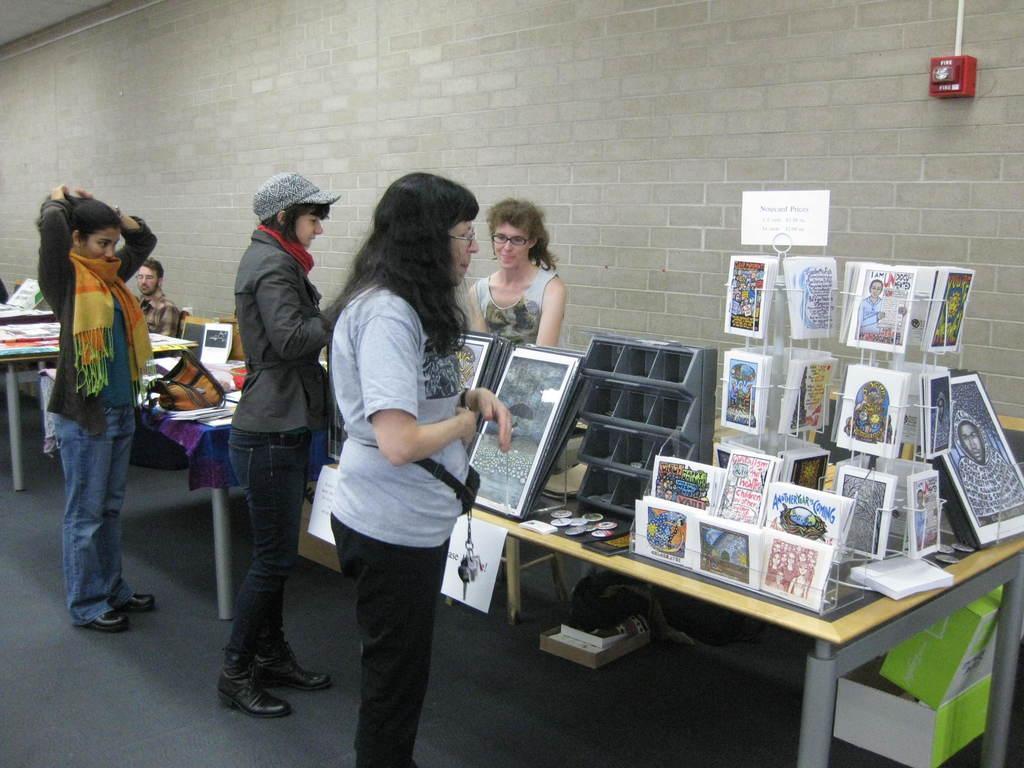Please provide a concise description of this image. In this image we can see there are three persons standing and watching photos which are arranged on the tables, on which there are other objects. Outside this table, there are two persons. One of them is sitting. On the right side, there are two boxes arranged under the table. In the background, there is a red color board with a white color pipe attached to the brick wall. 